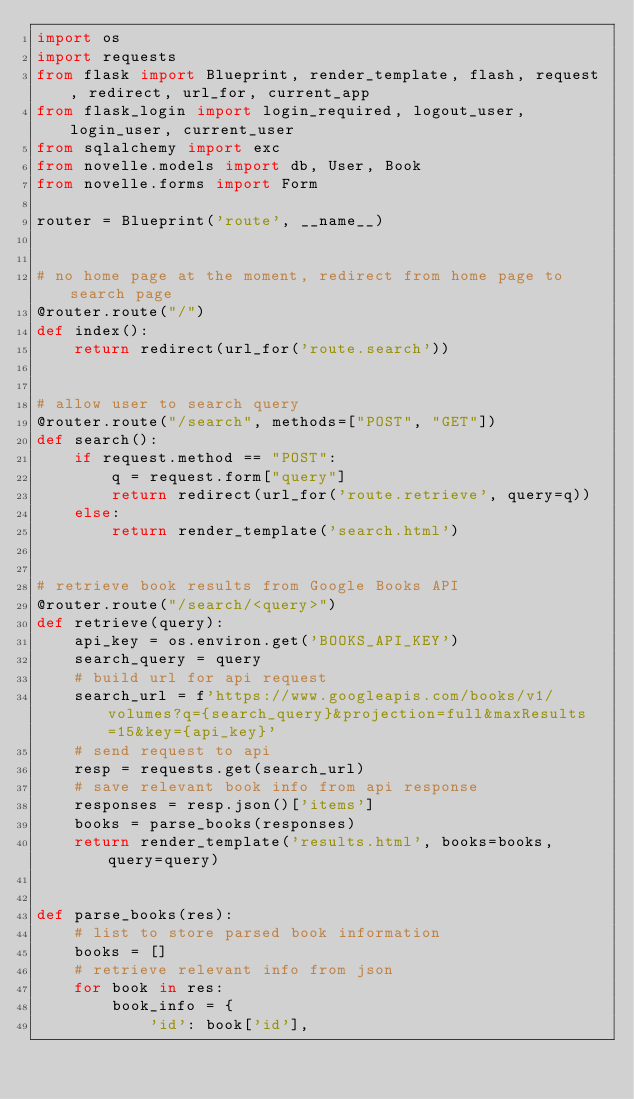Convert code to text. <code><loc_0><loc_0><loc_500><loc_500><_Python_>import os
import requests
from flask import Blueprint, render_template, flash, request, redirect, url_for, current_app
from flask_login import login_required, logout_user, login_user, current_user
from sqlalchemy import exc
from novelle.models import db, User, Book
from novelle.forms import Form

router = Blueprint('route', __name__)


# no home page at the moment, redirect from home page to search page
@router.route("/")
def index():
    return redirect(url_for('route.search'))


# allow user to search query
@router.route("/search", methods=["POST", "GET"])
def search():
    if request.method == "POST":
        q = request.form["query"]
        return redirect(url_for('route.retrieve', query=q))
    else:
        return render_template('search.html')


# retrieve book results from Google Books API
@router.route("/search/<query>")
def retrieve(query):
    api_key = os.environ.get('BOOKS_API_KEY')
    search_query = query
    # build url for api request
    search_url = f'https://www.googleapis.com/books/v1/volumes?q={search_query}&projection=full&maxResults=15&key={api_key}'
    # send request to api
    resp = requests.get(search_url)
    # save relevant book info from api response
    responses = resp.json()['items']
    books = parse_books(responses)
    return render_template('results.html', books=books, query=query)


def parse_books(res):
    # list to store parsed book information
    books = []
    # retrieve relevant info from json
    for book in res:
        book_info = {
            'id': book['id'],</code> 